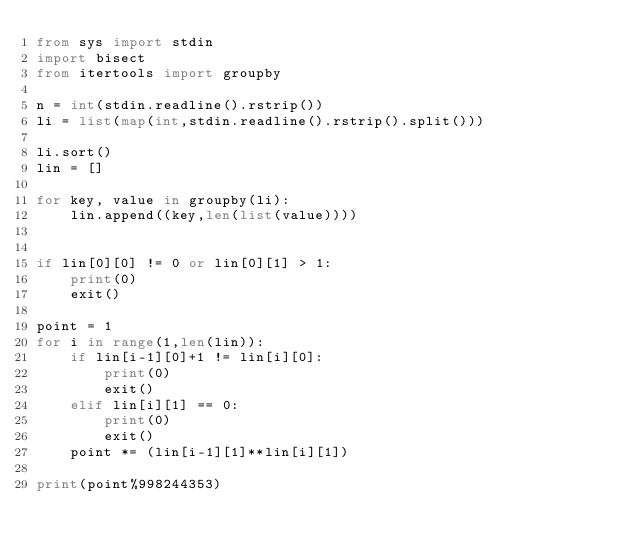Convert code to text. <code><loc_0><loc_0><loc_500><loc_500><_Python_>from sys import stdin
import bisect
from itertools import groupby
 
n = int(stdin.readline().rstrip())
li = list(map(int,stdin.readline().rstrip().split()))
 
li.sort()
lin = []

for key, value in groupby(li):
    lin.append((key,len(list(value))))


if lin[0][0] != 0 or lin[0][1] > 1:
    print(0)
    exit()

point = 1
for i in range(1,len(lin)):
    if lin[i-1][0]+1 != lin[i][0]:
        print(0)
        exit()
    elif lin[i][1] == 0:
        print(0)
        exit()
    point *= (lin[i-1][1]**lin[i][1])

print(point%998244353)
</code> 